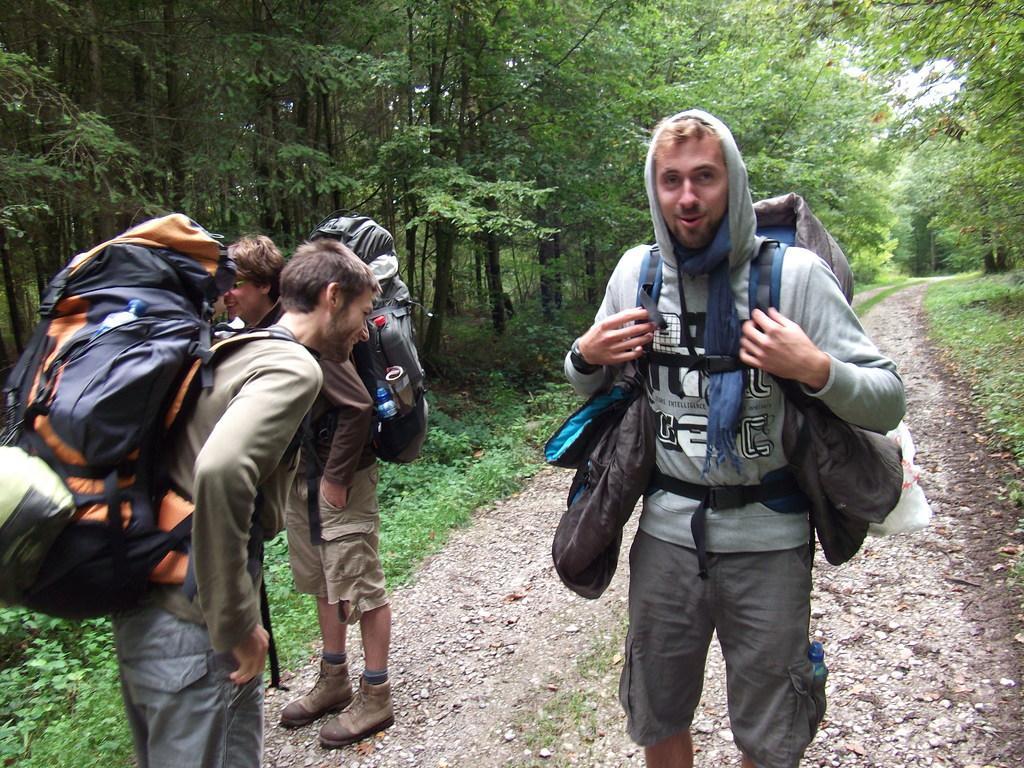Please provide a concise description of this image. In this image I can see three people standing on the road and wearing bags. In the background there are some trees and the sky 